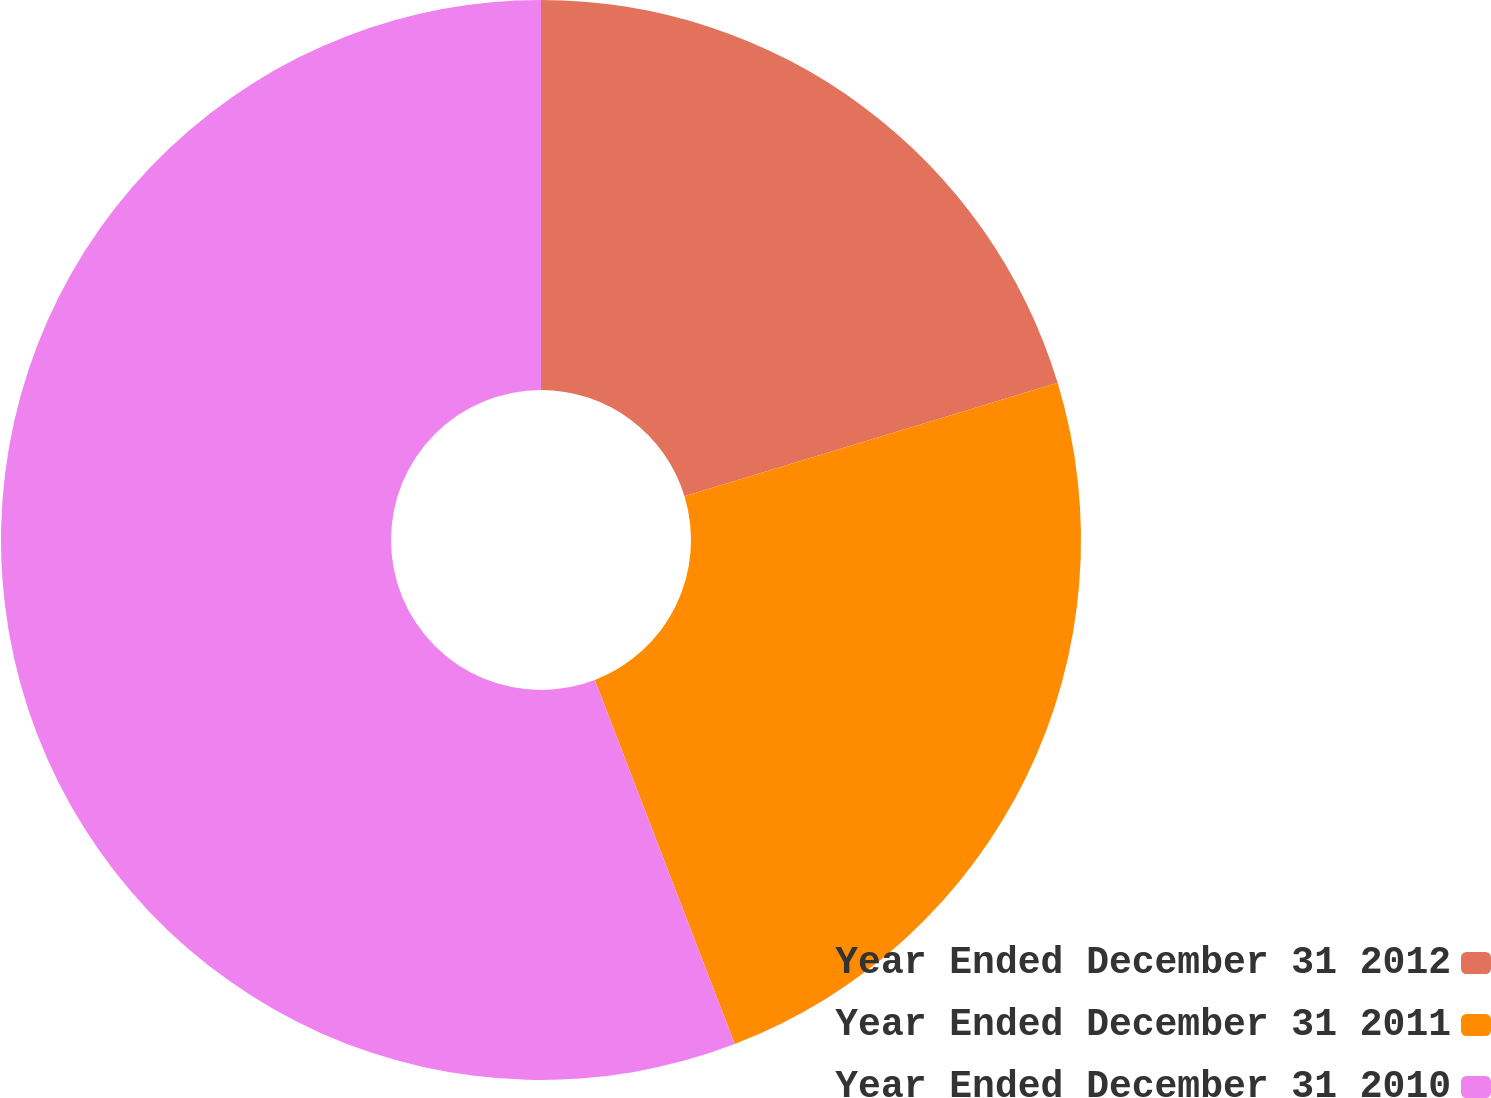Convert chart. <chart><loc_0><loc_0><loc_500><loc_500><pie_chart><fcel>Year Ended December 31 2012<fcel>Year Ended December 31 2011<fcel>Year Ended December 31 2010<nl><fcel>20.3%<fcel>23.86%<fcel>55.84%<nl></chart> 